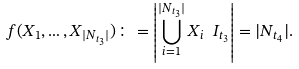Convert formula to latex. <formula><loc_0><loc_0><loc_500><loc_500>f ( X _ { 1 } , \dots , X _ { | N _ { t _ { 3 } } | } ) \colon = \left | \bigcup _ { i = 1 } ^ { | N _ { t _ { 3 } } | } X _ { i } \ I _ { t _ { 3 } } \right | = | N _ { t _ { 4 } } | .</formula> 